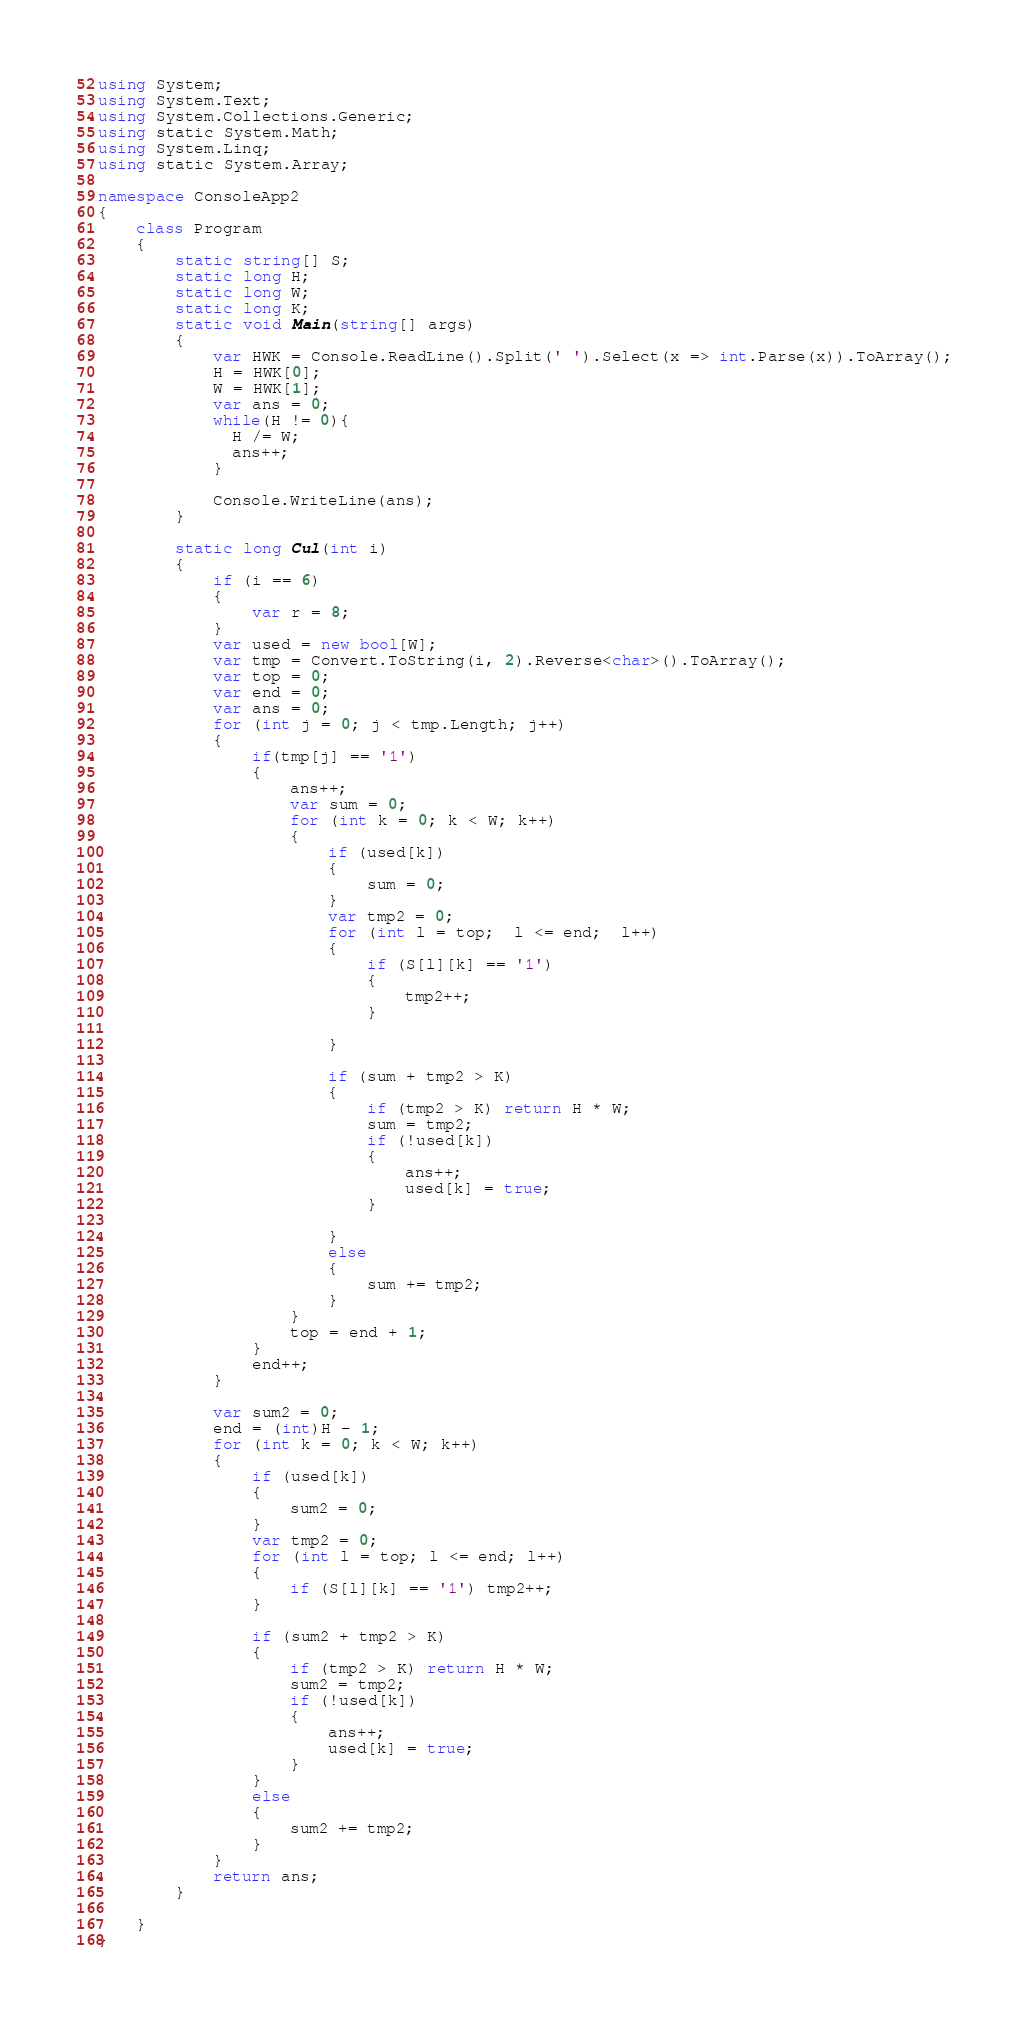Convert code to text. <code><loc_0><loc_0><loc_500><loc_500><_C#_>using System;
using System.Text;
using System.Collections.Generic;
using static System.Math;
using System.Linq;
using static System.Array;

namespace ConsoleApp2
{
    class Program
    {
        static string[] S;
        static long H;
        static long W;
        static long K;
        static void Main(string[] args)
        {
            var HWK = Console.ReadLine().Split(' ').Select(x => int.Parse(x)).ToArray();
            H = HWK[0];
            W = HWK[1];
            var ans = 0;
            while(H != 0){
              H /= W;
              ans++;
            }
          
            Console.WriteLine(ans); 
        }

        static long Cul(int i)
        {
            if (i == 6)
            {
                var r = 8;
            }
            var used = new bool[W];
            var tmp = Convert.ToString(i, 2).Reverse<char>().ToArray();
            var top = 0;
            var end = 0;
            var ans = 0;
            for (int j = 0; j < tmp.Length; j++)
            {
                if(tmp[j] == '1')
                {
                    ans++;
                    var sum = 0;
                    for (int k = 0; k < W; k++)
                    {
                        if (used[k])
                        {
                            sum = 0;
                        }
                        var tmp2 = 0;
                        for (int l = top;  l <= end;  l++)
                        {
                            if (S[l][k] == '1')
                            {
                                tmp2++;
                            }
                                
                        }

                        if (sum + tmp2 > K)
                        {
                            if (tmp2 > K) return H * W;
                            sum = tmp2;
                            if (!used[k])
                            {
                                ans++;
                                used[k] = true;
                            }
                            
                        }
                        else
                        {
                            sum += tmp2;
                        }
                    }
                    top = end + 1;
                }
                end++;
            }

            var sum2 = 0;
            end = (int)H - 1;
            for (int k = 0; k < W; k++)
            {
                if (used[k])
                {
                    sum2 = 0;
                }
                var tmp2 = 0;
                for (int l = top; l <= end; l++)
                {
                    if (S[l][k] == '1') tmp2++;
                }

                if (sum2 + tmp2 > K)
                {
                    if (tmp2 > K) return H * W;
                    sum2 = tmp2;
                    if (!used[k])
                    {
                        ans++;
                        used[k] = true;
                    }
                }
                else
                {
                    sum2 += tmp2;
                }
            }
            return ans;
        }

    }
}
</code> 